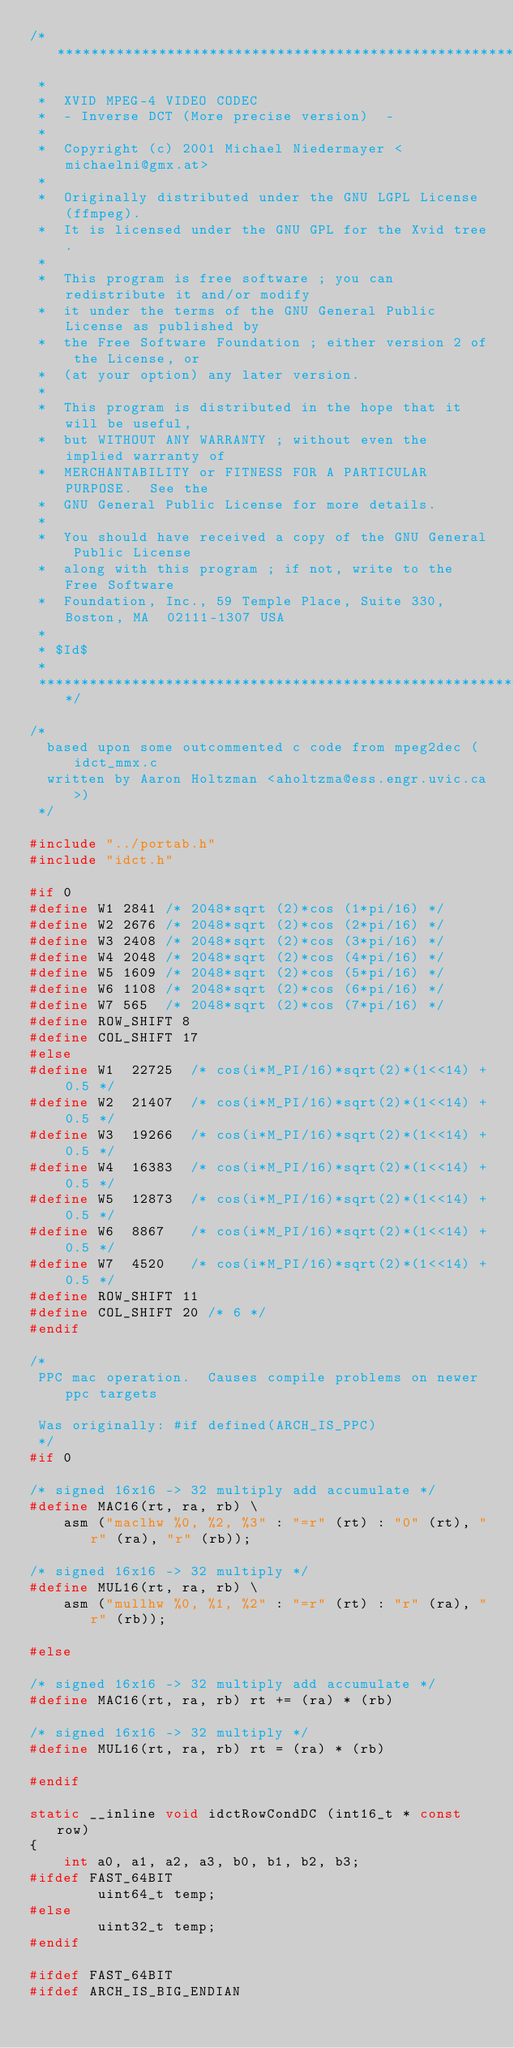Convert code to text. <code><loc_0><loc_0><loc_500><loc_500><_C_>/*****************************************************************************
 *
 *  XVID MPEG-4 VIDEO CODEC
 *  - Inverse DCT (More precise version)  -
 *
 *  Copyright (c) 2001 Michael Niedermayer <michaelni@gmx.at>
 *
 *  Originally distributed under the GNU LGPL License (ffmpeg).
 *  It is licensed under the GNU GPL for the Xvid tree.
 *
 *  This program is free software ; you can redistribute it and/or modify
 *  it under the terms of the GNU General Public License as published by
 *  the Free Software Foundation ; either version 2 of the License, or
 *  (at your option) any later version.
 *
 *  This program is distributed in the hope that it will be useful,
 *  but WITHOUT ANY WARRANTY ; without even the implied warranty of
 *  MERCHANTABILITY or FITNESS FOR A PARTICULAR PURPOSE.  See the
 *  GNU General Public License for more details.
 *
 *  You should have received a copy of the GNU General Public License
 *  along with this program ; if not, write to the Free Software
 *  Foundation, Inc., 59 Temple Place, Suite 330, Boston, MA  02111-1307 USA
 *
 * $Id$
 *
 ****************************************************************************/

/*
  based upon some outcommented c code from mpeg2dec (idct_mmx.c
  written by Aaron Holtzman <aholtzma@ess.engr.uvic.ca>)
 */

#include "../portab.h"
#include "idct.h"

#if 0
#define W1 2841 /* 2048*sqrt (2)*cos (1*pi/16) */
#define W2 2676 /* 2048*sqrt (2)*cos (2*pi/16) */
#define W3 2408 /* 2048*sqrt (2)*cos (3*pi/16) */
#define W4 2048 /* 2048*sqrt (2)*cos (4*pi/16) */
#define W5 1609 /* 2048*sqrt (2)*cos (5*pi/16) */
#define W6 1108 /* 2048*sqrt (2)*cos (6*pi/16) */
#define W7 565  /* 2048*sqrt (2)*cos (7*pi/16) */
#define ROW_SHIFT 8
#define COL_SHIFT 17
#else
#define W1  22725  /* cos(i*M_PI/16)*sqrt(2)*(1<<14) + 0.5 */
#define W2  21407  /* cos(i*M_PI/16)*sqrt(2)*(1<<14) + 0.5 */
#define W3  19266  /* cos(i*M_PI/16)*sqrt(2)*(1<<14) + 0.5 */
#define W4  16383  /* cos(i*M_PI/16)*sqrt(2)*(1<<14) + 0.5 */
#define W5  12873  /* cos(i*M_PI/16)*sqrt(2)*(1<<14) + 0.5 */
#define W6  8867   /* cos(i*M_PI/16)*sqrt(2)*(1<<14) + 0.5 */
#define W7  4520   /* cos(i*M_PI/16)*sqrt(2)*(1<<14) + 0.5 */
#define ROW_SHIFT 11
#define COL_SHIFT 20 /* 6 */
#endif

/*
 PPC mac operation.  Causes compile problems on newer ppc targets
 
 Was originally: #if defined(ARCH_IS_PPC)
 */
#if 0

/* signed 16x16 -> 32 multiply add accumulate */
#define MAC16(rt, ra, rb) \
    asm ("maclhw %0, %2, %3" : "=r" (rt) : "0" (rt), "r" (ra), "r" (rb));

/* signed 16x16 -> 32 multiply */
#define MUL16(rt, ra, rb) \
    asm ("mullhw %0, %1, %2" : "=r" (rt) : "r" (ra), "r" (rb));

#else

/* signed 16x16 -> 32 multiply add accumulate */
#define MAC16(rt, ra, rb) rt += (ra) * (rb)

/* signed 16x16 -> 32 multiply */
#define MUL16(rt, ra, rb) rt = (ra) * (rb)

#endif

static __inline void idctRowCondDC (int16_t * const row)
{
	int a0, a1, a2, a3, b0, b1, b2, b3;
#ifdef FAST_64BIT
        uint64_t temp;
#else
        uint32_t temp;
#endif

#ifdef FAST_64BIT
#ifdef ARCH_IS_BIG_ENDIAN</code> 